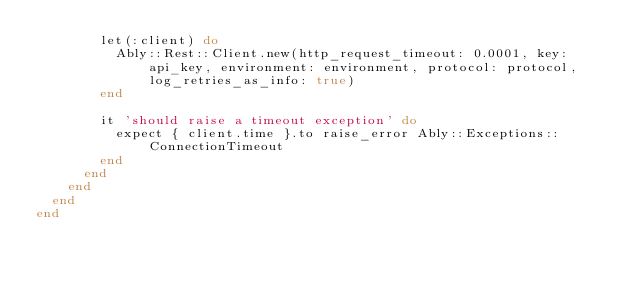Convert code to text. <code><loc_0><loc_0><loc_500><loc_500><_Ruby_>        let(:client) do
          Ably::Rest::Client.new(http_request_timeout: 0.0001, key: api_key, environment: environment, protocol: protocol, log_retries_as_info: true)
        end

        it 'should raise a timeout exception' do
          expect { client.time }.to raise_error Ably::Exceptions::ConnectionTimeout
        end
      end
    end
  end
end
</code> 